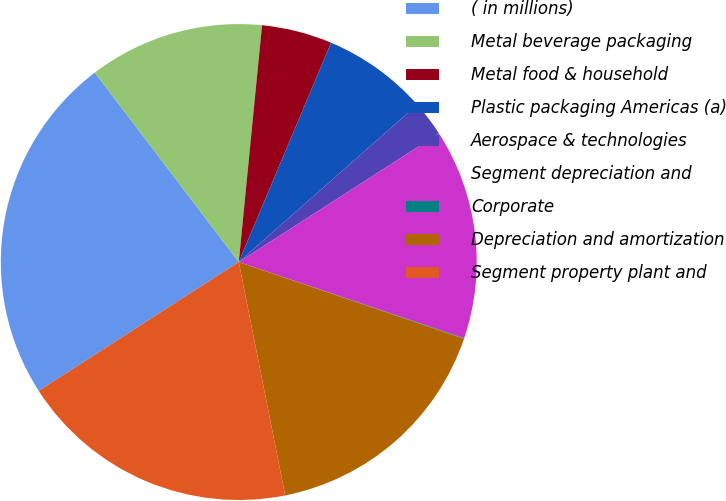Convert chart. <chart><loc_0><loc_0><loc_500><loc_500><pie_chart><fcel>( in millions)<fcel>Metal beverage packaging<fcel>Metal food & household<fcel>Plastic packaging Americas (a)<fcel>Aerospace & technologies<fcel>Segment depreciation and<fcel>Corporate<fcel>Depreciation and amortization<fcel>Segment property plant and<nl><fcel>23.76%<fcel>11.9%<fcel>4.78%<fcel>7.16%<fcel>2.41%<fcel>14.27%<fcel>0.04%<fcel>16.65%<fcel>19.02%<nl></chart> 